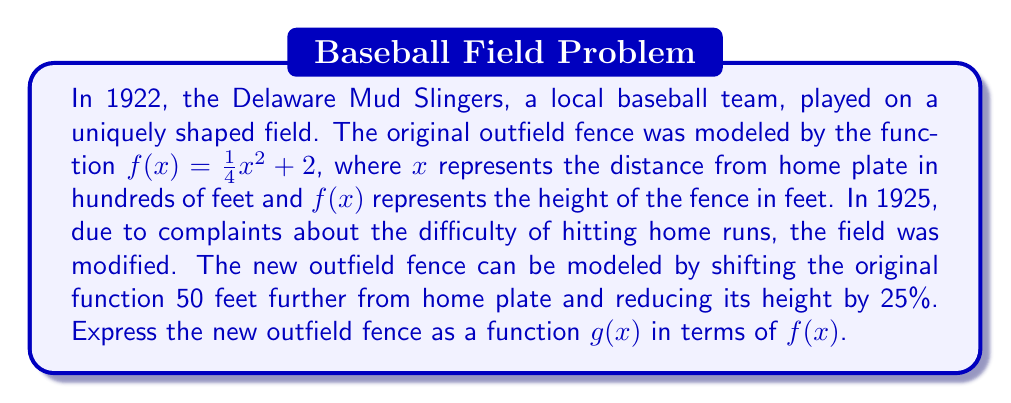Can you solve this math problem? To transform the original function $f(x)$ into the new function $g(x)$, we need to apply two transformations:

1. Horizontal shift: The fence is moved 50 feet further from home plate. Since $x$ is measured in hundreds of feet, this is a shift of 0.5 units to the right. We represent this by replacing $x$ with $(x - 0.5)$ in the function.

2. Vertical scaling: The height is reduced by 25%, which means the new height is 75% of the original height. We represent this by multiplying the function by 0.75.

Applying these transformations to $f(x)$, we get:

$$g(x) = 0.75 \cdot f(x - 0.5)$$

This means that for any input $x$, we first subtract 0.5, then apply the original function $f$, and finally multiply the result by 0.75.
Answer: $g(x) = 0.75 \cdot f(x - 0.5)$ 